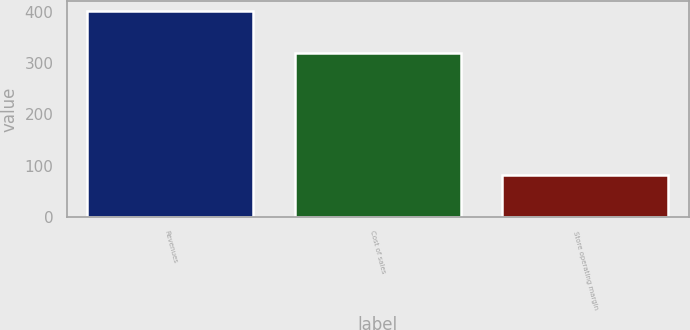Convert chart to OTSL. <chart><loc_0><loc_0><loc_500><loc_500><bar_chart><fcel>Revenues<fcel>Cost of sales<fcel>Store operating margin<nl><fcel>401<fcel>319.1<fcel>81.9<nl></chart> 